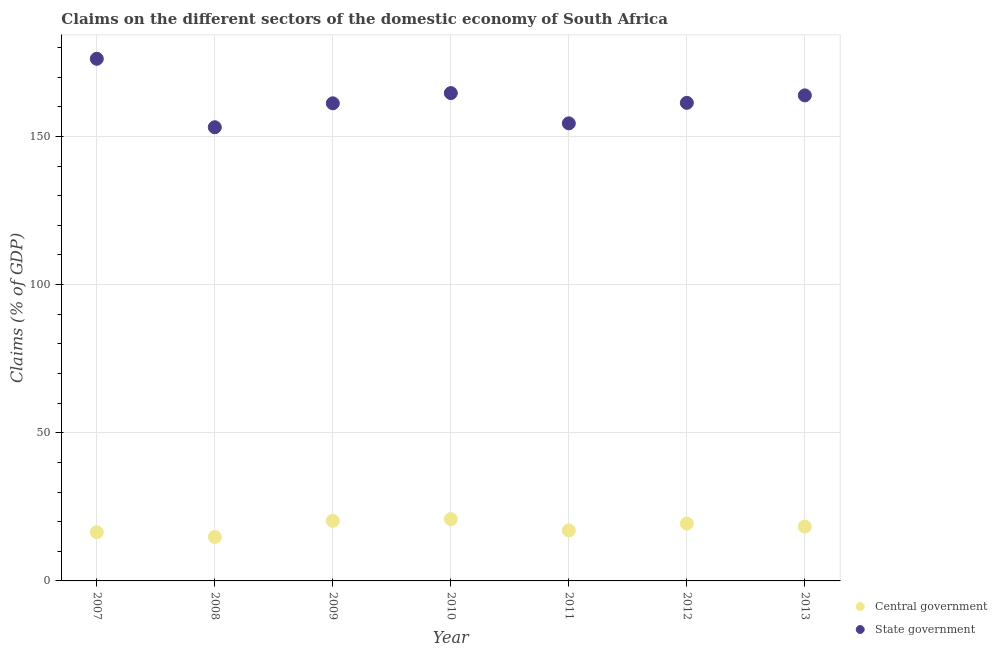Is the number of dotlines equal to the number of legend labels?
Your response must be concise. Yes. What is the claims on central government in 2011?
Keep it short and to the point. 17.04. Across all years, what is the maximum claims on central government?
Make the answer very short. 20.84. Across all years, what is the minimum claims on central government?
Offer a terse response. 14.84. In which year was the claims on state government maximum?
Provide a short and direct response. 2007. What is the total claims on central government in the graph?
Make the answer very short. 127.14. What is the difference between the claims on central government in 2010 and that in 2011?
Make the answer very short. 3.8. What is the difference between the claims on state government in 2011 and the claims on central government in 2013?
Your answer should be compact. 136.08. What is the average claims on central government per year?
Your answer should be compact. 18.16. In the year 2011, what is the difference between the claims on state government and claims on central government?
Your response must be concise. 137.37. What is the ratio of the claims on central government in 2007 to that in 2012?
Keep it short and to the point. 0.85. Is the claims on state government in 2008 less than that in 2012?
Your answer should be very brief. Yes. What is the difference between the highest and the second highest claims on central government?
Ensure brevity in your answer.  0.58. What is the difference between the highest and the lowest claims on state government?
Your response must be concise. 23.1. Is the sum of the claims on central government in 2010 and 2013 greater than the maximum claims on state government across all years?
Make the answer very short. No. Does the claims on state government monotonically increase over the years?
Your answer should be very brief. No. Is the claims on central government strictly greater than the claims on state government over the years?
Provide a succinct answer. No. Is the claims on state government strictly less than the claims on central government over the years?
Your response must be concise. No. What is the difference between two consecutive major ticks on the Y-axis?
Your response must be concise. 50. Does the graph contain grids?
Your answer should be compact. Yes. Where does the legend appear in the graph?
Offer a terse response. Bottom right. How many legend labels are there?
Your answer should be very brief. 2. What is the title of the graph?
Make the answer very short. Claims on the different sectors of the domestic economy of South Africa. What is the label or title of the Y-axis?
Your answer should be compact. Claims (% of GDP). What is the Claims (% of GDP) of Central government in 2007?
Offer a terse response. 16.45. What is the Claims (% of GDP) in State government in 2007?
Your response must be concise. 176.21. What is the Claims (% of GDP) in Central government in 2008?
Your answer should be compact. 14.84. What is the Claims (% of GDP) in State government in 2008?
Your answer should be very brief. 153.11. What is the Claims (% of GDP) of Central government in 2009?
Give a very brief answer. 20.27. What is the Claims (% of GDP) in State government in 2009?
Your response must be concise. 161.18. What is the Claims (% of GDP) in Central government in 2010?
Your answer should be very brief. 20.84. What is the Claims (% of GDP) of State government in 2010?
Your response must be concise. 164.63. What is the Claims (% of GDP) of Central government in 2011?
Your answer should be very brief. 17.04. What is the Claims (% of GDP) in State government in 2011?
Make the answer very short. 154.42. What is the Claims (% of GDP) of Central government in 2012?
Your answer should be very brief. 19.36. What is the Claims (% of GDP) in State government in 2012?
Provide a short and direct response. 161.34. What is the Claims (% of GDP) in Central government in 2013?
Provide a short and direct response. 18.34. What is the Claims (% of GDP) of State government in 2013?
Your answer should be compact. 163.86. Across all years, what is the maximum Claims (% of GDP) of Central government?
Your response must be concise. 20.84. Across all years, what is the maximum Claims (% of GDP) in State government?
Your answer should be very brief. 176.21. Across all years, what is the minimum Claims (% of GDP) in Central government?
Provide a short and direct response. 14.84. Across all years, what is the minimum Claims (% of GDP) in State government?
Your response must be concise. 153.11. What is the total Claims (% of GDP) in Central government in the graph?
Your response must be concise. 127.14. What is the total Claims (% of GDP) of State government in the graph?
Your answer should be compact. 1134.75. What is the difference between the Claims (% of GDP) in Central government in 2007 and that in 2008?
Ensure brevity in your answer.  1.62. What is the difference between the Claims (% of GDP) of State government in 2007 and that in 2008?
Give a very brief answer. 23.1. What is the difference between the Claims (% of GDP) in Central government in 2007 and that in 2009?
Your response must be concise. -3.82. What is the difference between the Claims (% of GDP) in State government in 2007 and that in 2009?
Your response must be concise. 15.03. What is the difference between the Claims (% of GDP) of Central government in 2007 and that in 2010?
Ensure brevity in your answer.  -4.39. What is the difference between the Claims (% of GDP) in State government in 2007 and that in 2010?
Offer a terse response. 11.58. What is the difference between the Claims (% of GDP) of Central government in 2007 and that in 2011?
Offer a terse response. -0.59. What is the difference between the Claims (% of GDP) of State government in 2007 and that in 2011?
Keep it short and to the point. 21.79. What is the difference between the Claims (% of GDP) of Central government in 2007 and that in 2012?
Offer a very short reply. -2.91. What is the difference between the Claims (% of GDP) in State government in 2007 and that in 2012?
Provide a succinct answer. 14.87. What is the difference between the Claims (% of GDP) in Central government in 2007 and that in 2013?
Keep it short and to the point. -1.89. What is the difference between the Claims (% of GDP) in State government in 2007 and that in 2013?
Your answer should be compact. 12.35. What is the difference between the Claims (% of GDP) in Central government in 2008 and that in 2009?
Keep it short and to the point. -5.43. What is the difference between the Claims (% of GDP) of State government in 2008 and that in 2009?
Give a very brief answer. -8.08. What is the difference between the Claims (% of GDP) of Central government in 2008 and that in 2010?
Keep it short and to the point. -6.01. What is the difference between the Claims (% of GDP) in State government in 2008 and that in 2010?
Offer a terse response. -11.52. What is the difference between the Claims (% of GDP) in Central government in 2008 and that in 2011?
Provide a short and direct response. -2.21. What is the difference between the Claims (% of GDP) in State government in 2008 and that in 2011?
Offer a terse response. -1.31. What is the difference between the Claims (% of GDP) of Central government in 2008 and that in 2012?
Provide a short and direct response. -4.53. What is the difference between the Claims (% of GDP) in State government in 2008 and that in 2012?
Make the answer very short. -8.23. What is the difference between the Claims (% of GDP) in Central government in 2008 and that in 2013?
Give a very brief answer. -3.51. What is the difference between the Claims (% of GDP) in State government in 2008 and that in 2013?
Keep it short and to the point. -10.76. What is the difference between the Claims (% of GDP) of Central government in 2009 and that in 2010?
Keep it short and to the point. -0.58. What is the difference between the Claims (% of GDP) in State government in 2009 and that in 2010?
Make the answer very short. -3.45. What is the difference between the Claims (% of GDP) of Central government in 2009 and that in 2011?
Provide a succinct answer. 3.22. What is the difference between the Claims (% of GDP) in State government in 2009 and that in 2011?
Give a very brief answer. 6.76. What is the difference between the Claims (% of GDP) of Central government in 2009 and that in 2012?
Your response must be concise. 0.91. What is the difference between the Claims (% of GDP) of State government in 2009 and that in 2012?
Your answer should be compact. -0.16. What is the difference between the Claims (% of GDP) of Central government in 2009 and that in 2013?
Provide a succinct answer. 1.93. What is the difference between the Claims (% of GDP) in State government in 2009 and that in 2013?
Offer a very short reply. -2.68. What is the difference between the Claims (% of GDP) in State government in 2010 and that in 2011?
Your response must be concise. 10.21. What is the difference between the Claims (% of GDP) in Central government in 2010 and that in 2012?
Offer a very short reply. 1.48. What is the difference between the Claims (% of GDP) in State government in 2010 and that in 2012?
Ensure brevity in your answer.  3.29. What is the difference between the Claims (% of GDP) of Central government in 2010 and that in 2013?
Make the answer very short. 2.5. What is the difference between the Claims (% of GDP) of State government in 2010 and that in 2013?
Ensure brevity in your answer.  0.77. What is the difference between the Claims (% of GDP) of Central government in 2011 and that in 2012?
Your response must be concise. -2.32. What is the difference between the Claims (% of GDP) in State government in 2011 and that in 2012?
Your response must be concise. -6.92. What is the difference between the Claims (% of GDP) in Central government in 2011 and that in 2013?
Ensure brevity in your answer.  -1.3. What is the difference between the Claims (% of GDP) in State government in 2011 and that in 2013?
Give a very brief answer. -9.44. What is the difference between the Claims (% of GDP) in Central government in 2012 and that in 2013?
Offer a very short reply. 1.02. What is the difference between the Claims (% of GDP) of State government in 2012 and that in 2013?
Your response must be concise. -2.52. What is the difference between the Claims (% of GDP) of Central government in 2007 and the Claims (% of GDP) of State government in 2008?
Ensure brevity in your answer.  -136.66. What is the difference between the Claims (% of GDP) of Central government in 2007 and the Claims (% of GDP) of State government in 2009?
Ensure brevity in your answer.  -144.73. What is the difference between the Claims (% of GDP) of Central government in 2007 and the Claims (% of GDP) of State government in 2010?
Ensure brevity in your answer.  -148.18. What is the difference between the Claims (% of GDP) in Central government in 2007 and the Claims (% of GDP) in State government in 2011?
Give a very brief answer. -137.97. What is the difference between the Claims (% of GDP) of Central government in 2007 and the Claims (% of GDP) of State government in 2012?
Make the answer very short. -144.89. What is the difference between the Claims (% of GDP) of Central government in 2007 and the Claims (% of GDP) of State government in 2013?
Provide a succinct answer. -147.41. What is the difference between the Claims (% of GDP) in Central government in 2008 and the Claims (% of GDP) in State government in 2009?
Provide a short and direct response. -146.35. What is the difference between the Claims (% of GDP) in Central government in 2008 and the Claims (% of GDP) in State government in 2010?
Your answer should be compact. -149.8. What is the difference between the Claims (% of GDP) in Central government in 2008 and the Claims (% of GDP) in State government in 2011?
Provide a short and direct response. -139.58. What is the difference between the Claims (% of GDP) in Central government in 2008 and the Claims (% of GDP) in State government in 2012?
Keep it short and to the point. -146.5. What is the difference between the Claims (% of GDP) of Central government in 2008 and the Claims (% of GDP) of State government in 2013?
Offer a terse response. -149.03. What is the difference between the Claims (% of GDP) of Central government in 2009 and the Claims (% of GDP) of State government in 2010?
Make the answer very short. -144.36. What is the difference between the Claims (% of GDP) in Central government in 2009 and the Claims (% of GDP) in State government in 2011?
Offer a terse response. -134.15. What is the difference between the Claims (% of GDP) in Central government in 2009 and the Claims (% of GDP) in State government in 2012?
Offer a very short reply. -141.07. What is the difference between the Claims (% of GDP) of Central government in 2009 and the Claims (% of GDP) of State government in 2013?
Give a very brief answer. -143.6. What is the difference between the Claims (% of GDP) in Central government in 2010 and the Claims (% of GDP) in State government in 2011?
Ensure brevity in your answer.  -133.57. What is the difference between the Claims (% of GDP) in Central government in 2010 and the Claims (% of GDP) in State government in 2012?
Offer a very short reply. -140.49. What is the difference between the Claims (% of GDP) of Central government in 2010 and the Claims (% of GDP) of State government in 2013?
Ensure brevity in your answer.  -143.02. What is the difference between the Claims (% of GDP) of Central government in 2011 and the Claims (% of GDP) of State government in 2012?
Offer a very short reply. -144.29. What is the difference between the Claims (% of GDP) in Central government in 2011 and the Claims (% of GDP) in State government in 2013?
Offer a very short reply. -146.82. What is the difference between the Claims (% of GDP) in Central government in 2012 and the Claims (% of GDP) in State government in 2013?
Your answer should be very brief. -144.5. What is the average Claims (% of GDP) in Central government per year?
Ensure brevity in your answer.  18.16. What is the average Claims (% of GDP) of State government per year?
Ensure brevity in your answer.  162.11. In the year 2007, what is the difference between the Claims (% of GDP) in Central government and Claims (% of GDP) in State government?
Make the answer very short. -159.76. In the year 2008, what is the difference between the Claims (% of GDP) of Central government and Claims (% of GDP) of State government?
Ensure brevity in your answer.  -138.27. In the year 2009, what is the difference between the Claims (% of GDP) in Central government and Claims (% of GDP) in State government?
Your answer should be compact. -140.92. In the year 2010, what is the difference between the Claims (% of GDP) in Central government and Claims (% of GDP) in State government?
Provide a succinct answer. -143.79. In the year 2011, what is the difference between the Claims (% of GDP) of Central government and Claims (% of GDP) of State government?
Your answer should be compact. -137.37. In the year 2012, what is the difference between the Claims (% of GDP) of Central government and Claims (% of GDP) of State government?
Ensure brevity in your answer.  -141.98. In the year 2013, what is the difference between the Claims (% of GDP) of Central government and Claims (% of GDP) of State government?
Give a very brief answer. -145.52. What is the ratio of the Claims (% of GDP) of Central government in 2007 to that in 2008?
Your answer should be compact. 1.11. What is the ratio of the Claims (% of GDP) in State government in 2007 to that in 2008?
Give a very brief answer. 1.15. What is the ratio of the Claims (% of GDP) of Central government in 2007 to that in 2009?
Offer a terse response. 0.81. What is the ratio of the Claims (% of GDP) of State government in 2007 to that in 2009?
Provide a succinct answer. 1.09. What is the ratio of the Claims (% of GDP) of Central government in 2007 to that in 2010?
Provide a short and direct response. 0.79. What is the ratio of the Claims (% of GDP) of State government in 2007 to that in 2010?
Offer a terse response. 1.07. What is the ratio of the Claims (% of GDP) of Central government in 2007 to that in 2011?
Offer a terse response. 0.97. What is the ratio of the Claims (% of GDP) in State government in 2007 to that in 2011?
Your answer should be compact. 1.14. What is the ratio of the Claims (% of GDP) of Central government in 2007 to that in 2012?
Provide a succinct answer. 0.85. What is the ratio of the Claims (% of GDP) of State government in 2007 to that in 2012?
Provide a succinct answer. 1.09. What is the ratio of the Claims (% of GDP) of Central government in 2007 to that in 2013?
Offer a very short reply. 0.9. What is the ratio of the Claims (% of GDP) in State government in 2007 to that in 2013?
Ensure brevity in your answer.  1.08. What is the ratio of the Claims (% of GDP) in Central government in 2008 to that in 2009?
Offer a terse response. 0.73. What is the ratio of the Claims (% of GDP) of State government in 2008 to that in 2009?
Provide a short and direct response. 0.95. What is the ratio of the Claims (% of GDP) in Central government in 2008 to that in 2010?
Offer a very short reply. 0.71. What is the ratio of the Claims (% of GDP) in State government in 2008 to that in 2010?
Provide a succinct answer. 0.93. What is the ratio of the Claims (% of GDP) of Central government in 2008 to that in 2011?
Provide a succinct answer. 0.87. What is the ratio of the Claims (% of GDP) in State government in 2008 to that in 2011?
Your answer should be very brief. 0.99. What is the ratio of the Claims (% of GDP) in Central government in 2008 to that in 2012?
Your answer should be very brief. 0.77. What is the ratio of the Claims (% of GDP) of State government in 2008 to that in 2012?
Offer a very short reply. 0.95. What is the ratio of the Claims (% of GDP) in Central government in 2008 to that in 2013?
Your answer should be very brief. 0.81. What is the ratio of the Claims (% of GDP) of State government in 2008 to that in 2013?
Offer a terse response. 0.93. What is the ratio of the Claims (% of GDP) of Central government in 2009 to that in 2010?
Provide a short and direct response. 0.97. What is the ratio of the Claims (% of GDP) of State government in 2009 to that in 2010?
Provide a succinct answer. 0.98. What is the ratio of the Claims (% of GDP) in Central government in 2009 to that in 2011?
Offer a very short reply. 1.19. What is the ratio of the Claims (% of GDP) in State government in 2009 to that in 2011?
Provide a succinct answer. 1.04. What is the ratio of the Claims (% of GDP) in Central government in 2009 to that in 2012?
Make the answer very short. 1.05. What is the ratio of the Claims (% of GDP) in State government in 2009 to that in 2012?
Provide a short and direct response. 1. What is the ratio of the Claims (% of GDP) in Central government in 2009 to that in 2013?
Your answer should be very brief. 1.1. What is the ratio of the Claims (% of GDP) in State government in 2009 to that in 2013?
Offer a very short reply. 0.98. What is the ratio of the Claims (% of GDP) of Central government in 2010 to that in 2011?
Keep it short and to the point. 1.22. What is the ratio of the Claims (% of GDP) in State government in 2010 to that in 2011?
Make the answer very short. 1.07. What is the ratio of the Claims (% of GDP) in Central government in 2010 to that in 2012?
Give a very brief answer. 1.08. What is the ratio of the Claims (% of GDP) in State government in 2010 to that in 2012?
Ensure brevity in your answer.  1.02. What is the ratio of the Claims (% of GDP) of Central government in 2010 to that in 2013?
Keep it short and to the point. 1.14. What is the ratio of the Claims (% of GDP) in State government in 2010 to that in 2013?
Offer a very short reply. 1. What is the ratio of the Claims (% of GDP) of Central government in 2011 to that in 2012?
Make the answer very short. 0.88. What is the ratio of the Claims (% of GDP) in State government in 2011 to that in 2012?
Keep it short and to the point. 0.96. What is the ratio of the Claims (% of GDP) in Central government in 2011 to that in 2013?
Your answer should be very brief. 0.93. What is the ratio of the Claims (% of GDP) of State government in 2011 to that in 2013?
Ensure brevity in your answer.  0.94. What is the ratio of the Claims (% of GDP) in Central government in 2012 to that in 2013?
Keep it short and to the point. 1.06. What is the ratio of the Claims (% of GDP) in State government in 2012 to that in 2013?
Offer a very short reply. 0.98. What is the difference between the highest and the second highest Claims (% of GDP) in Central government?
Offer a very short reply. 0.58. What is the difference between the highest and the second highest Claims (% of GDP) in State government?
Keep it short and to the point. 11.58. What is the difference between the highest and the lowest Claims (% of GDP) of Central government?
Keep it short and to the point. 6.01. What is the difference between the highest and the lowest Claims (% of GDP) of State government?
Offer a very short reply. 23.1. 